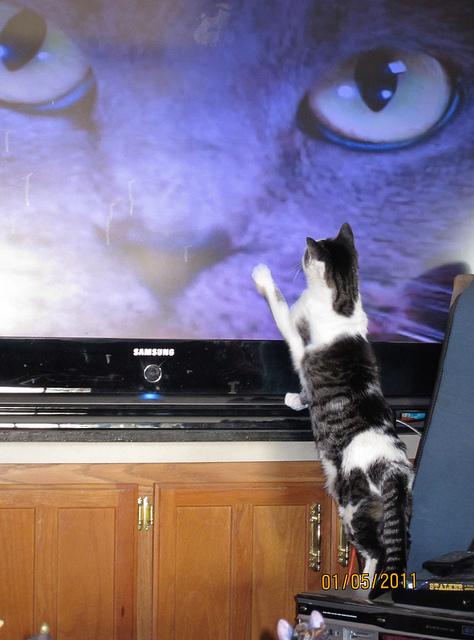Which brand of television is the cat watching?
Keep it brief. Samsung. What kind of TV is shown?
Keep it brief. Flat screen. What is on the TV?
Be succinct. Cat. 